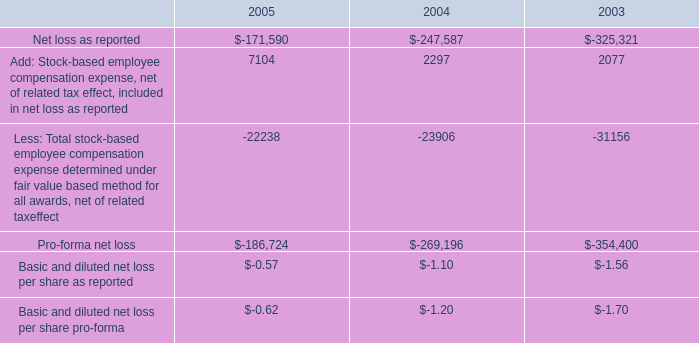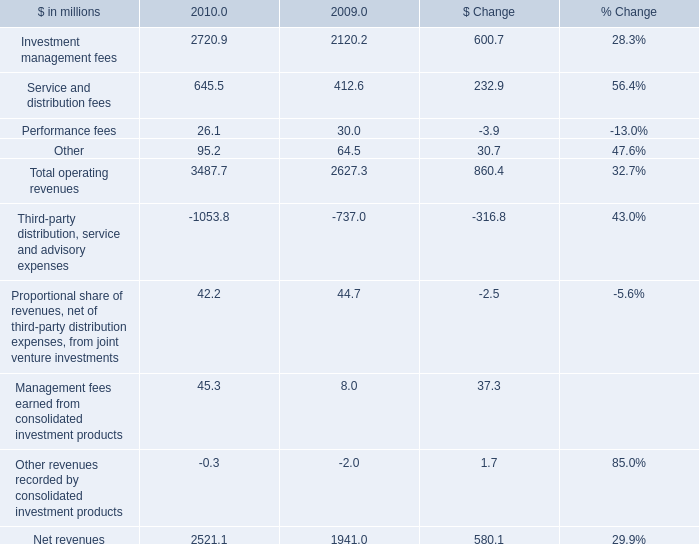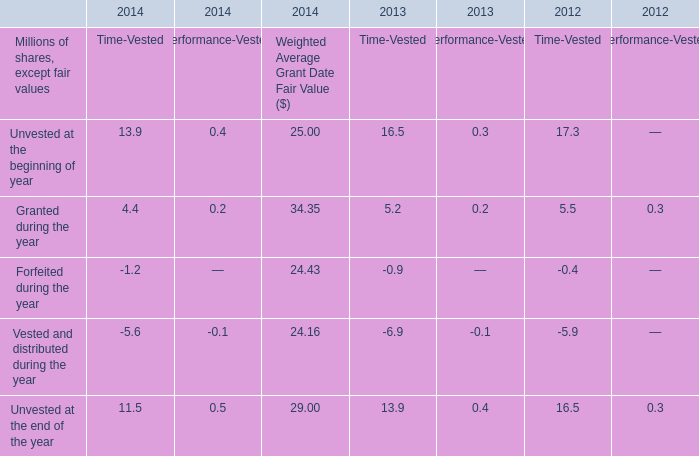what was the ratio of the recognized charges based on the modification of vesting and exercise terms for certain terminated for the year 2005 and 2004 
Computations: (7 / 3)
Answer: 2.33333. 